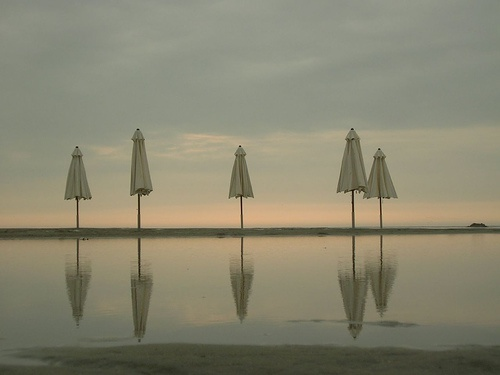Describe the objects in this image and their specific colors. I can see umbrella in gray, darkgreen, and black tones, umbrella in gray, darkgreen, and black tones, umbrella in gray and tan tones, umbrella in gray, darkgreen, and black tones, and umbrella in gray, darkgreen, and darkgray tones in this image. 